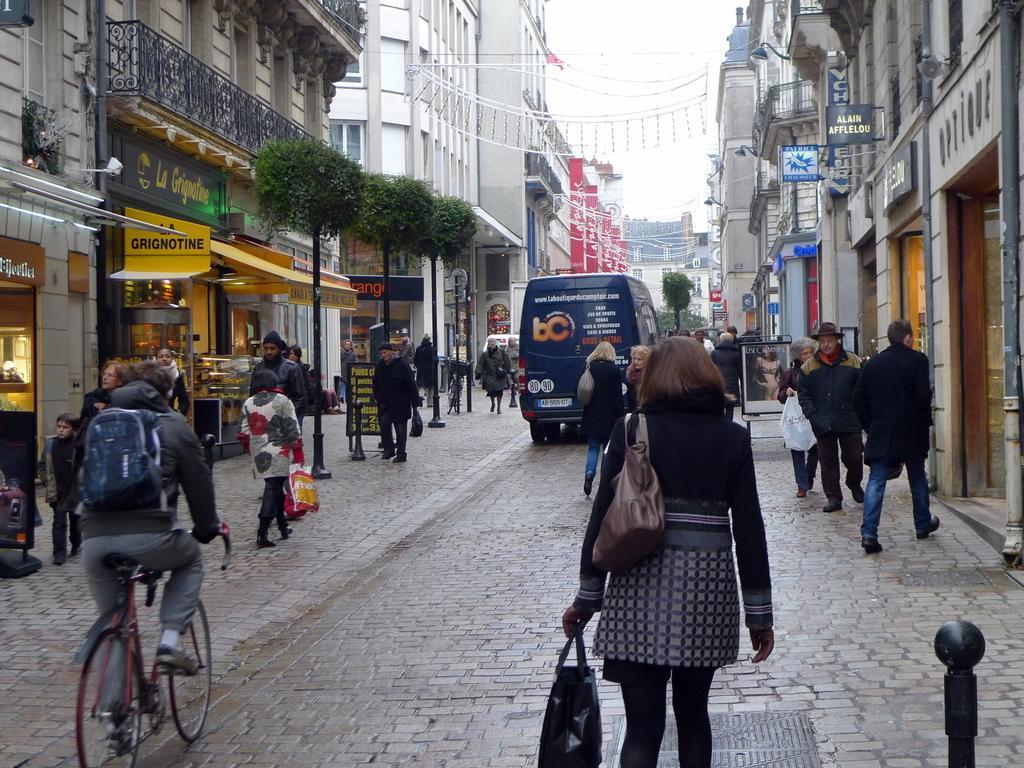Can you describe this image briefly? In this image we can see a man riding a bicycle on the road and he is on the left side. Here we can see a bag on his back. Here we can see a few people walking on the road. Here we can see the handbag. Here we can see the buildings on the left side and the right side as well. Here we can see the trees. 